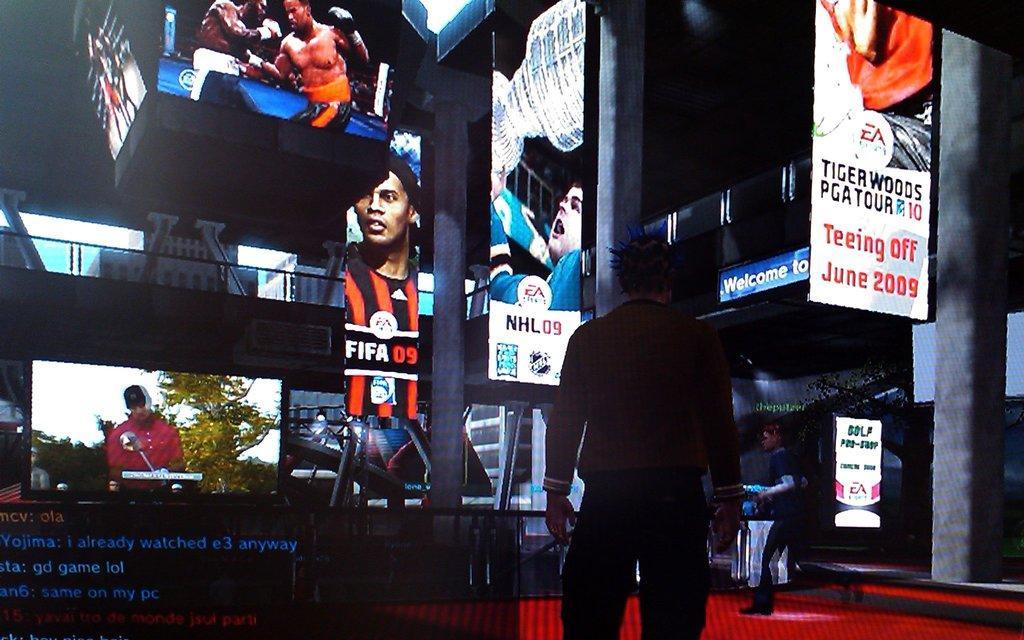Please provide a concise description of this image. Here this picture is an animated image, in which in the middle we can see a person standing and in front of him we can see all digital screens present over there. 